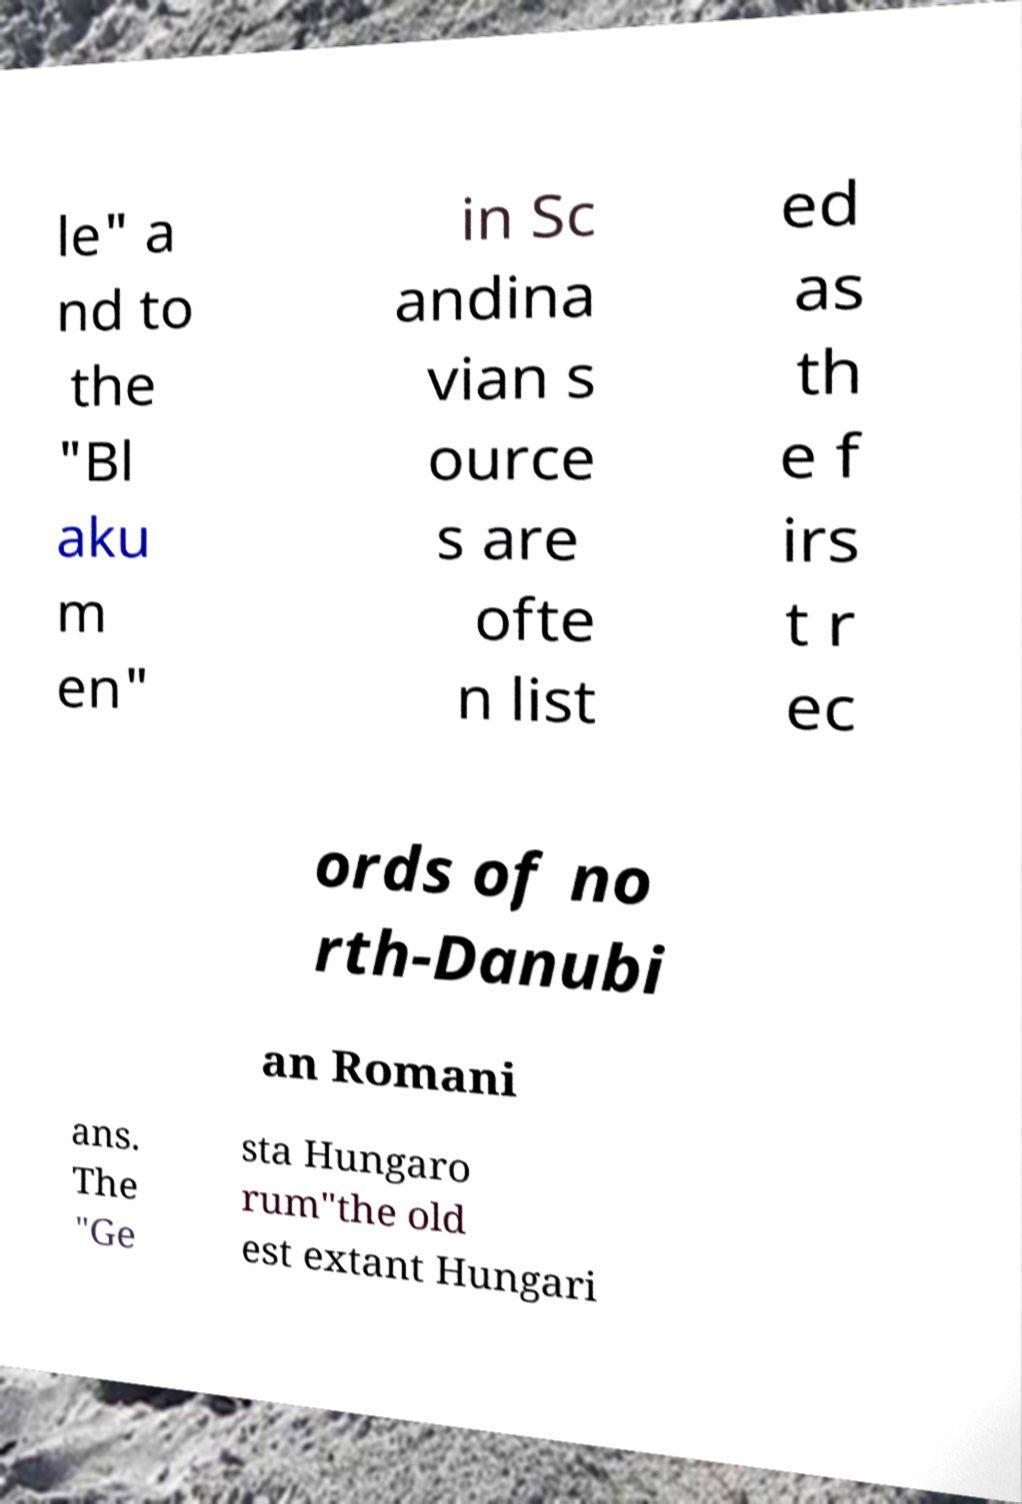Please identify and transcribe the text found in this image. le" a nd to the "Bl aku m en" in Sc andina vian s ource s are ofte n list ed as th e f irs t r ec ords of no rth-Danubi an Romani ans. The "Ge sta Hungaro rum"the old est extant Hungari 